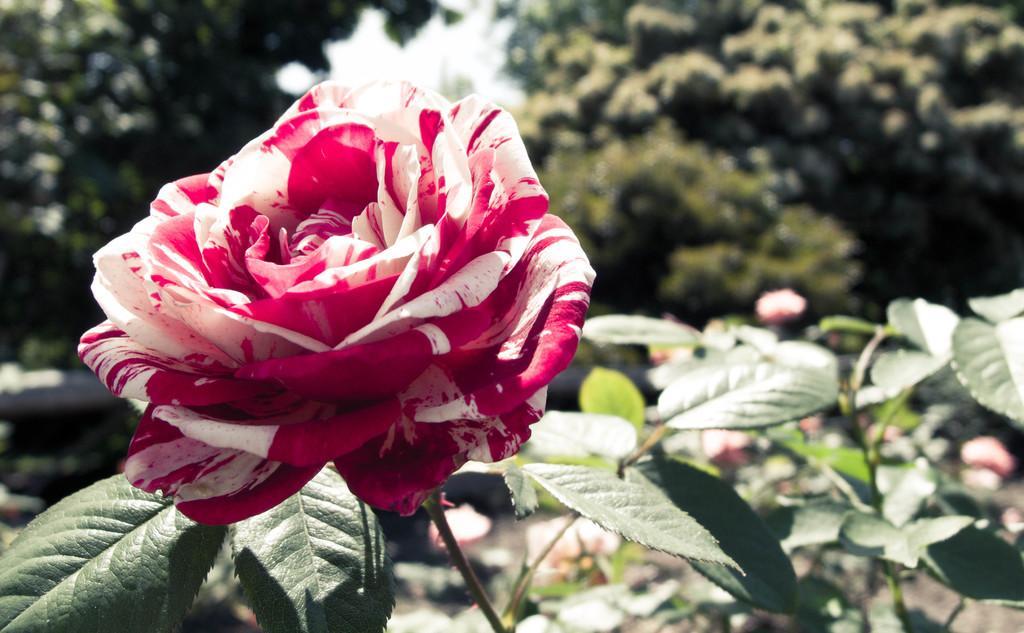In one or two sentences, can you explain what this image depicts? In this image in the front there is a flower and there are leaves. In the background there are trees. 